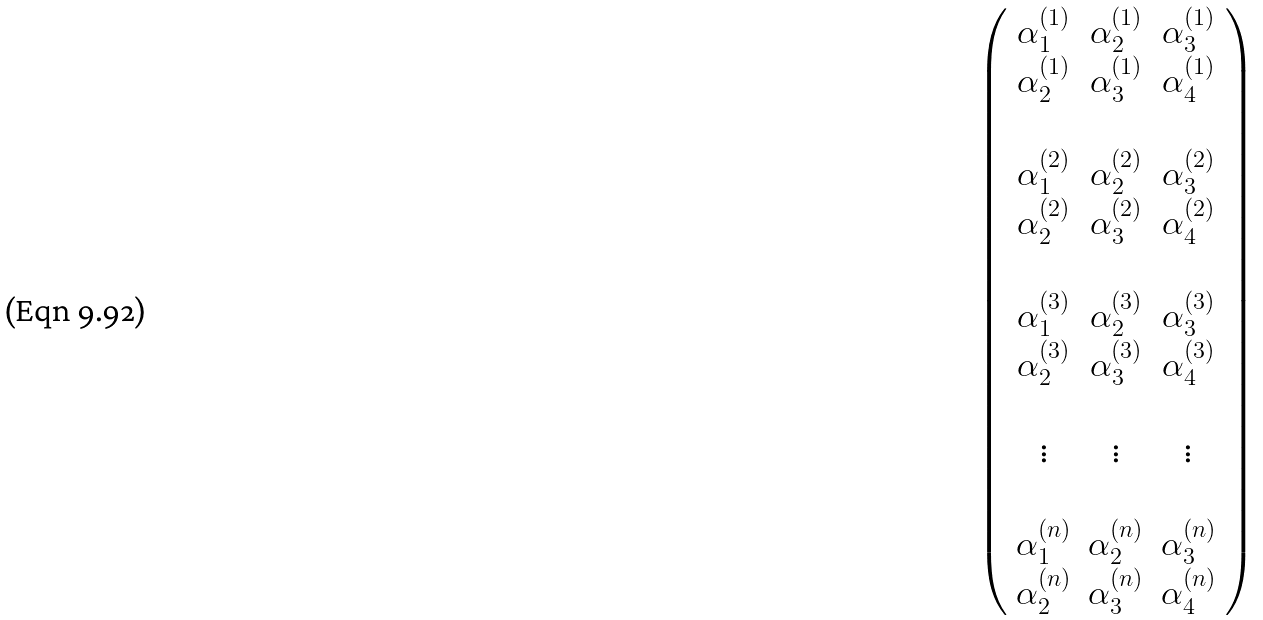<formula> <loc_0><loc_0><loc_500><loc_500>\left ( \begin{array} { c c c } \alpha _ { 1 } ^ { ( 1 ) } & \alpha _ { 2 } ^ { ( 1 ) } & \alpha _ { 3 } ^ { ( 1 ) } \\ \alpha _ { 2 } ^ { ( 1 ) } & \alpha _ { 3 } ^ { ( 1 ) } & \alpha _ { 4 } ^ { ( 1 ) } \\ \\ \alpha _ { 1 } ^ { ( 2 ) } & \alpha _ { 2 } ^ { ( 2 ) } & \alpha _ { 3 } ^ { ( 2 ) } \\ \alpha _ { 2 } ^ { ( 2 ) } & \alpha _ { 3 } ^ { ( 2 ) } & \alpha _ { 4 } ^ { ( 2 ) } \\ \\ \alpha _ { 1 } ^ { ( 3 ) } & \alpha _ { 2 } ^ { ( 3 ) } & \alpha _ { 3 } ^ { ( 3 ) } \\ \alpha _ { 2 } ^ { ( 3 ) } & \alpha _ { 3 } ^ { ( 3 ) } & \alpha _ { 4 } ^ { ( 3 ) } \\ \\ \vdots & \vdots & \vdots \\ \\ \alpha _ { 1 } ^ { ( n ) } & \alpha _ { 2 } ^ { ( n ) } & \alpha _ { 3 } ^ { ( n ) } \\ \alpha _ { 2 } ^ { ( n ) } & \alpha _ { 3 } ^ { ( n ) } & \alpha _ { 4 } ^ { ( n ) } \\ \end{array} \right )</formula> 